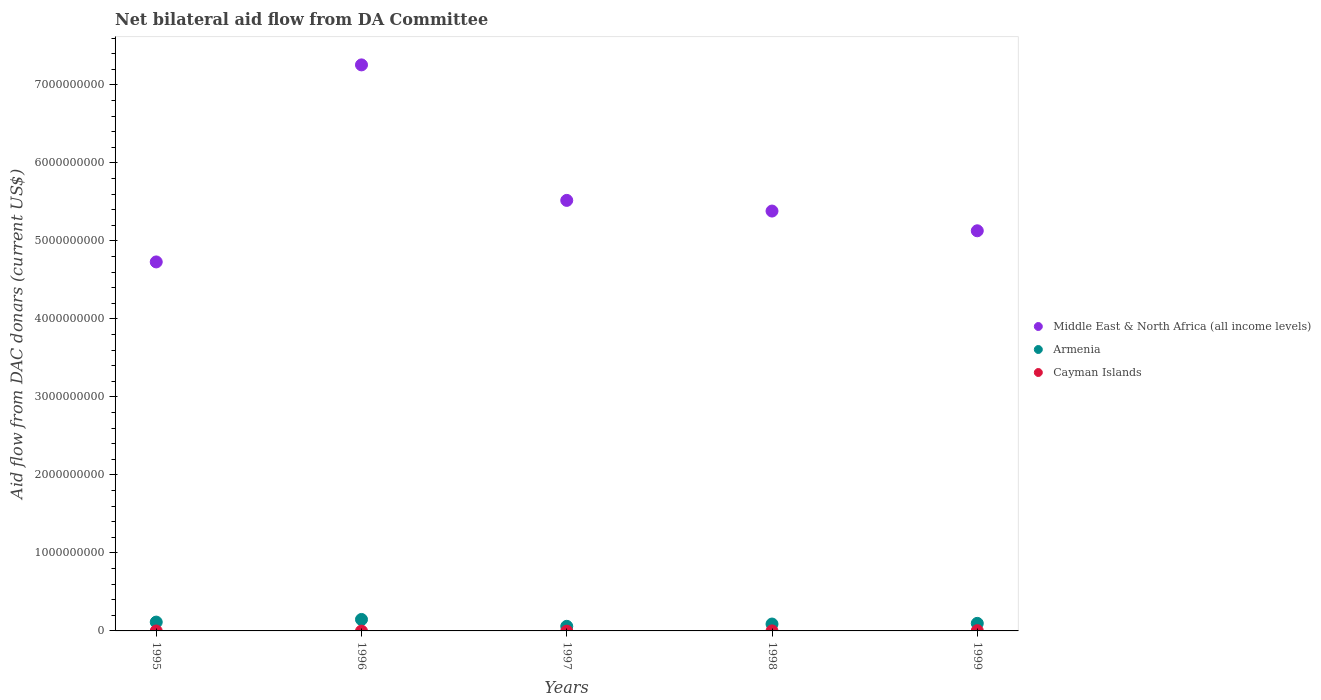How many different coloured dotlines are there?
Your answer should be very brief. 3. Is the number of dotlines equal to the number of legend labels?
Make the answer very short. No. What is the aid flow in in Middle East & North Africa (all income levels) in 1997?
Ensure brevity in your answer.  5.52e+09. Across all years, what is the maximum aid flow in in Cayman Islands?
Ensure brevity in your answer.  3.29e+06. Across all years, what is the minimum aid flow in in Armenia?
Provide a short and direct response. 5.89e+07. In which year was the aid flow in in Middle East & North Africa (all income levels) maximum?
Ensure brevity in your answer.  1996. What is the total aid flow in in Middle East & North Africa (all income levels) in the graph?
Your answer should be compact. 2.80e+1. What is the difference between the aid flow in in Armenia in 1998 and that in 1999?
Keep it short and to the point. -8.67e+06. What is the difference between the aid flow in in Armenia in 1999 and the aid flow in in Middle East & North Africa (all income levels) in 1996?
Ensure brevity in your answer.  -7.16e+09. What is the average aid flow in in Cayman Islands per year?
Provide a short and direct response. 7.04e+05. In the year 1998, what is the difference between the aid flow in in Armenia and aid flow in in Middle East & North Africa (all income levels)?
Provide a succinct answer. -5.29e+09. What is the ratio of the aid flow in in Middle East & North Africa (all income levels) in 1995 to that in 1999?
Provide a short and direct response. 0.92. Is the difference between the aid flow in in Armenia in 1997 and 1999 greater than the difference between the aid flow in in Middle East & North Africa (all income levels) in 1997 and 1999?
Give a very brief answer. No. What is the difference between the highest and the second highest aid flow in in Armenia?
Offer a very short reply. 3.38e+07. What is the difference between the highest and the lowest aid flow in in Cayman Islands?
Ensure brevity in your answer.  3.29e+06. In how many years, is the aid flow in in Middle East & North Africa (all income levels) greater than the average aid flow in in Middle East & North Africa (all income levels) taken over all years?
Offer a very short reply. 1. Is the sum of the aid flow in in Middle East & North Africa (all income levels) in 1997 and 1998 greater than the maximum aid flow in in Cayman Islands across all years?
Keep it short and to the point. Yes. Is it the case that in every year, the sum of the aid flow in in Armenia and aid flow in in Cayman Islands  is greater than the aid flow in in Middle East & North Africa (all income levels)?
Provide a short and direct response. No. How many years are there in the graph?
Offer a very short reply. 5. What is the difference between two consecutive major ticks on the Y-axis?
Provide a succinct answer. 1.00e+09. Where does the legend appear in the graph?
Ensure brevity in your answer.  Center right. How are the legend labels stacked?
Ensure brevity in your answer.  Vertical. What is the title of the graph?
Keep it short and to the point. Net bilateral aid flow from DA Committee. What is the label or title of the Y-axis?
Provide a short and direct response. Aid flow from DAC donars (current US$). What is the Aid flow from DAC donars (current US$) in Middle East & North Africa (all income levels) in 1995?
Make the answer very short. 4.73e+09. What is the Aid flow from DAC donars (current US$) in Armenia in 1995?
Give a very brief answer. 1.13e+08. What is the Aid flow from DAC donars (current US$) of Cayman Islands in 1995?
Your answer should be very brief. 0. What is the Aid flow from DAC donars (current US$) of Middle East & North Africa (all income levels) in 1996?
Provide a short and direct response. 7.26e+09. What is the Aid flow from DAC donars (current US$) of Armenia in 1996?
Provide a short and direct response. 1.47e+08. What is the Aid flow from DAC donars (current US$) in Cayman Islands in 1996?
Offer a terse response. 0. What is the Aid flow from DAC donars (current US$) of Middle East & North Africa (all income levels) in 1997?
Your response must be concise. 5.52e+09. What is the Aid flow from DAC donars (current US$) in Armenia in 1997?
Ensure brevity in your answer.  5.89e+07. What is the Aid flow from DAC donars (current US$) in Cayman Islands in 1997?
Ensure brevity in your answer.  0. What is the Aid flow from DAC donars (current US$) in Middle East & North Africa (all income levels) in 1998?
Your response must be concise. 5.38e+09. What is the Aid flow from DAC donars (current US$) of Armenia in 1998?
Your answer should be compact. 8.82e+07. What is the Aid flow from DAC donars (current US$) in Middle East & North Africa (all income levels) in 1999?
Your answer should be very brief. 5.13e+09. What is the Aid flow from DAC donars (current US$) of Armenia in 1999?
Offer a very short reply. 9.69e+07. What is the Aid flow from DAC donars (current US$) in Cayman Islands in 1999?
Ensure brevity in your answer.  3.29e+06. Across all years, what is the maximum Aid flow from DAC donars (current US$) in Middle East & North Africa (all income levels)?
Give a very brief answer. 7.26e+09. Across all years, what is the maximum Aid flow from DAC donars (current US$) in Armenia?
Your response must be concise. 1.47e+08. Across all years, what is the maximum Aid flow from DAC donars (current US$) in Cayman Islands?
Your answer should be very brief. 3.29e+06. Across all years, what is the minimum Aid flow from DAC donars (current US$) in Middle East & North Africa (all income levels)?
Provide a short and direct response. 4.73e+09. Across all years, what is the minimum Aid flow from DAC donars (current US$) in Armenia?
Provide a short and direct response. 5.89e+07. What is the total Aid flow from DAC donars (current US$) in Middle East & North Africa (all income levels) in the graph?
Your response must be concise. 2.80e+1. What is the total Aid flow from DAC donars (current US$) in Armenia in the graph?
Make the answer very short. 5.04e+08. What is the total Aid flow from DAC donars (current US$) in Cayman Islands in the graph?
Keep it short and to the point. 3.52e+06. What is the difference between the Aid flow from DAC donars (current US$) of Middle East & North Africa (all income levels) in 1995 and that in 1996?
Offer a terse response. -2.53e+09. What is the difference between the Aid flow from DAC donars (current US$) in Armenia in 1995 and that in 1996?
Make the answer very short. -3.38e+07. What is the difference between the Aid flow from DAC donars (current US$) in Middle East & North Africa (all income levels) in 1995 and that in 1997?
Offer a very short reply. -7.89e+08. What is the difference between the Aid flow from DAC donars (current US$) of Armenia in 1995 and that in 1997?
Provide a short and direct response. 5.43e+07. What is the difference between the Aid flow from DAC donars (current US$) in Middle East & North Africa (all income levels) in 1995 and that in 1998?
Ensure brevity in your answer.  -6.52e+08. What is the difference between the Aid flow from DAC donars (current US$) of Armenia in 1995 and that in 1998?
Ensure brevity in your answer.  2.50e+07. What is the difference between the Aid flow from DAC donars (current US$) of Middle East & North Africa (all income levels) in 1995 and that in 1999?
Offer a very short reply. -3.99e+08. What is the difference between the Aid flow from DAC donars (current US$) of Armenia in 1995 and that in 1999?
Keep it short and to the point. 1.63e+07. What is the difference between the Aid flow from DAC donars (current US$) of Middle East & North Africa (all income levels) in 1996 and that in 1997?
Offer a very short reply. 1.74e+09. What is the difference between the Aid flow from DAC donars (current US$) in Armenia in 1996 and that in 1997?
Keep it short and to the point. 8.81e+07. What is the difference between the Aid flow from DAC donars (current US$) in Middle East & North Africa (all income levels) in 1996 and that in 1998?
Your response must be concise. 1.87e+09. What is the difference between the Aid flow from DAC donars (current US$) in Armenia in 1996 and that in 1998?
Keep it short and to the point. 5.88e+07. What is the difference between the Aid flow from DAC donars (current US$) of Middle East & North Africa (all income levels) in 1996 and that in 1999?
Provide a short and direct response. 2.13e+09. What is the difference between the Aid flow from DAC donars (current US$) in Armenia in 1996 and that in 1999?
Offer a very short reply. 5.01e+07. What is the difference between the Aid flow from DAC donars (current US$) of Middle East & North Africa (all income levels) in 1997 and that in 1998?
Provide a succinct answer. 1.37e+08. What is the difference between the Aid flow from DAC donars (current US$) of Armenia in 1997 and that in 1998?
Your response must be concise. -2.93e+07. What is the difference between the Aid flow from DAC donars (current US$) of Middle East & North Africa (all income levels) in 1997 and that in 1999?
Offer a very short reply. 3.90e+08. What is the difference between the Aid flow from DAC donars (current US$) in Armenia in 1997 and that in 1999?
Your answer should be compact. -3.80e+07. What is the difference between the Aid flow from DAC donars (current US$) of Middle East & North Africa (all income levels) in 1998 and that in 1999?
Your answer should be very brief. 2.53e+08. What is the difference between the Aid flow from DAC donars (current US$) in Armenia in 1998 and that in 1999?
Offer a very short reply. -8.67e+06. What is the difference between the Aid flow from DAC donars (current US$) of Cayman Islands in 1998 and that in 1999?
Your answer should be very brief. -3.06e+06. What is the difference between the Aid flow from DAC donars (current US$) in Middle East & North Africa (all income levels) in 1995 and the Aid flow from DAC donars (current US$) in Armenia in 1996?
Your response must be concise. 4.58e+09. What is the difference between the Aid flow from DAC donars (current US$) in Middle East & North Africa (all income levels) in 1995 and the Aid flow from DAC donars (current US$) in Armenia in 1997?
Provide a short and direct response. 4.67e+09. What is the difference between the Aid flow from DAC donars (current US$) in Middle East & North Africa (all income levels) in 1995 and the Aid flow from DAC donars (current US$) in Armenia in 1998?
Make the answer very short. 4.64e+09. What is the difference between the Aid flow from DAC donars (current US$) in Middle East & North Africa (all income levels) in 1995 and the Aid flow from DAC donars (current US$) in Cayman Islands in 1998?
Offer a very short reply. 4.73e+09. What is the difference between the Aid flow from DAC donars (current US$) in Armenia in 1995 and the Aid flow from DAC donars (current US$) in Cayman Islands in 1998?
Provide a short and direct response. 1.13e+08. What is the difference between the Aid flow from DAC donars (current US$) in Middle East & North Africa (all income levels) in 1995 and the Aid flow from DAC donars (current US$) in Armenia in 1999?
Offer a terse response. 4.63e+09. What is the difference between the Aid flow from DAC donars (current US$) of Middle East & North Africa (all income levels) in 1995 and the Aid flow from DAC donars (current US$) of Cayman Islands in 1999?
Your response must be concise. 4.73e+09. What is the difference between the Aid flow from DAC donars (current US$) of Armenia in 1995 and the Aid flow from DAC donars (current US$) of Cayman Islands in 1999?
Ensure brevity in your answer.  1.10e+08. What is the difference between the Aid flow from DAC donars (current US$) in Middle East & North Africa (all income levels) in 1996 and the Aid flow from DAC donars (current US$) in Armenia in 1997?
Offer a very short reply. 7.20e+09. What is the difference between the Aid flow from DAC donars (current US$) in Middle East & North Africa (all income levels) in 1996 and the Aid flow from DAC donars (current US$) in Armenia in 1998?
Give a very brief answer. 7.17e+09. What is the difference between the Aid flow from DAC donars (current US$) in Middle East & North Africa (all income levels) in 1996 and the Aid flow from DAC donars (current US$) in Cayman Islands in 1998?
Provide a short and direct response. 7.26e+09. What is the difference between the Aid flow from DAC donars (current US$) of Armenia in 1996 and the Aid flow from DAC donars (current US$) of Cayman Islands in 1998?
Ensure brevity in your answer.  1.47e+08. What is the difference between the Aid flow from DAC donars (current US$) in Middle East & North Africa (all income levels) in 1996 and the Aid flow from DAC donars (current US$) in Armenia in 1999?
Make the answer very short. 7.16e+09. What is the difference between the Aid flow from DAC donars (current US$) in Middle East & North Africa (all income levels) in 1996 and the Aid flow from DAC donars (current US$) in Cayman Islands in 1999?
Make the answer very short. 7.25e+09. What is the difference between the Aid flow from DAC donars (current US$) in Armenia in 1996 and the Aid flow from DAC donars (current US$) in Cayman Islands in 1999?
Your answer should be compact. 1.44e+08. What is the difference between the Aid flow from DAC donars (current US$) in Middle East & North Africa (all income levels) in 1997 and the Aid flow from DAC donars (current US$) in Armenia in 1998?
Make the answer very short. 5.43e+09. What is the difference between the Aid flow from DAC donars (current US$) in Middle East & North Africa (all income levels) in 1997 and the Aid flow from DAC donars (current US$) in Cayman Islands in 1998?
Ensure brevity in your answer.  5.52e+09. What is the difference between the Aid flow from DAC donars (current US$) in Armenia in 1997 and the Aid flow from DAC donars (current US$) in Cayman Islands in 1998?
Your answer should be very brief. 5.87e+07. What is the difference between the Aid flow from DAC donars (current US$) in Middle East & North Africa (all income levels) in 1997 and the Aid flow from DAC donars (current US$) in Armenia in 1999?
Keep it short and to the point. 5.42e+09. What is the difference between the Aid flow from DAC donars (current US$) of Middle East & North Africa (all income levels) in 1997 and the Aid flow from DAC donars (current US$) of Cayman Islands in 1999?
Keep it short and to the point. 5.52e+09. What is the difference between the Aid flow from DAC donars (current US$) in Armenia in 1997 and the Aid flow from DAC donars (current US$) in Cayman Islands in 1999?
Give a very brief answer. 5.56e+07. What is the difference between the Aid flow from DAC donars (current US$) in Middle East & North Africa (all income levels) in 1998 and the Aid flow from DAC donars (current US$) in Armenia in 1999?
Ensure brevity in your answer.  5.29e+09. What is the difference between the Aid flow from DAC donars (current US$) of Middle East & North Africa (all income levels) in 1998 and the Aid flow from DAC donars (current US$) of Cayman Islands in 1999?
Ensure brevity in your answer.  5.38e+09. What is the difference between the Aid flow from DAC donars (current US$) in Armenia in 1998 and the Aid flow from DAC donars (current US$) in Cayman Islands in 1999?
Your answer should be compact. 8.49e+07. What is the average Aid flow from DAC donars (current US$) of Middle East & North Africa (all income levels) per year?
Give a very brief answer. 5.60e+09. What is the average Aid flow from DAC donars (current US$) of Armenia per year?
Give a very brief answer. 1.01e+08. What is the average Aid flow from DAC donars (current US$) of Cayman Islands per year?
Your answer should be compact. 7.04e+05. In the year 1995, what is the difference between the Aid flow from DAC donars (current US$) in Middle East & North Africa (all income levels) and Aid flow from DAC donars (current US$) in Armenia?
Offer a terse response. 4.62e+09. In the year 1996, what is the difference between the Aid flow from DAC donars (current US$) in Middle East & North Africa (all income levels) and Aid flow from DAC donars (current US$) in Armenia?
Provide a succinct answer. 7.11e+09. In the year 1997, what is the difference between the Aid flow from DAC donars (current US$) of Middle East & North Africa (all income levels) and Aid flow from DAC donars (current US$) of Armenia?
Keep it short and to the point. 5.46e+09. In the year 1998, what is the difference between the Aid flow from DAC donars (current US$) in Middle East & North Africa (all income levels) and Aid flow from DAC donars (current US$) in Armenia?
Your response must be concise. 5.29e+09. In the year 1998, what is the difference between the Aid flow from DAC donars (current US$) in Middle East & North Africa (all income levels) and Aid flow from DAC donars (current US$) in Cayman Islands?
Offer a very short reply. 5.38e+09. In the year 1998, what is the difference between the Aid flow from DAC donars (current US$) in Armenia and Aid flow from DAC donars (current US$) in Cayman Islands?
Your response must be concise. 8.80e+07. In the year 1999, what is the difference between the Aid flow from DAC donars (current US$) of Middle East & North Africa (all income levels) and Aid flow from DAC donars (current US$) of Armenia?
Ensure brevity in your answer.  5.03e+09. In the year 1999, what is the difference between the Aid flow from DAC donars (current US$) of Middle East & North Africa (all income levels) and Aid flow from DAC donars (current US$) of Cayman Islands?
Your answer should be very brief. 5.13e+09. In the year 1999, what is the difference between the Aid flow from DAC donars (current US$) of Armenia and Aid flow from DAC donars (current US$) of Cayman Islands?
Offer a terse response. 9.36e+07. What is the ratio of the Aid flow from DAC donars (current US$) of Middle East & North Africa (all income levels) in 1995 to that in 1996?
Give a very brief answer. 0.65. What is the ratio of the Aid flow from DAC donars (current US$) of Armenia in 1995 to that in 1996?
Keep it short and to the point. 0.77. What is the ratio of the Aid flow from DAC donars (current US$) of Armenia in 1995 to that in 1997?
Your answer should be very brief. 1.92. What is the ratio of the Aid flow from DAC donars (current US$) in Middle East & North Africa (all income levels) in 1995 to that in 1998?
Offer a very short reply. 0.88. What is the ratio of the Aid flow from DAC donars (current US$) of Armenia in 1995 to that in 1998?
Provide a short and direct response. 1.28. What is the ratio of the Aid flow from DAC donars (current US$) of Middle East & North Africa (all income levels) in 1995 to that in 1999?
Make the answer very short. 0.92. What is the ratio of the Aid flow from DAC donars (current US$) of Armenia in 1995 to that in 1999?
Ensure brevity in your answer.  1.17. What is the ratio of the Aid flow from DAC donars (current US$) in Middle East & North Africa (all income levels) in 1996 to that in 1997?
Your answer should be compact. 1.31. What is the ratio of the Aid flow from DAC donars (current US$) in Armenia in 1996 to that in 1997?
Provide a succinct answer. 2.49. What is the ratio of the Aid flow from DAC donars (current US$) in Middle East & North Africa (all income levels) in 1996 to that in 1998?
Offer a terse response. 1.35. What is the ratio of the Aid flow from DAC donars (current US$) in Armenia in 1996 to that in 1998?
Provide a short and direct response. 1.67. What is the ratio of the Aid flow from DAC donars (current US$) of Middle East & North Africa (all income levels) in 1996 to that in 1999?
Provide a short and direct response. 1.41. What is the ratio of the Aid flow from DAC donars (current US$) of Armenia in 1996 to that in 1999?
Keep it short and to the point. 1.52. What is the ratio of the Aid flow from DAC donars (current US$) of Middle East & North Africa (all income levels) in 1997 to that in 1998?
Offer a terse response. 1.03. What is the ratio of the Aid flow from DAC donars (current US$) in Armenia in 1997 to that in 1998?
Offer a terse response. 0.67. What is the ratio of the Aid flow from DAC donars (current US$) of Middle East & North Africa (all income levels) in 1997 to that in 1999?
Make the answer very short. 1.08. What is the ratio of the Aid flow from DAC donars (current US$) of Armenia in 1997 to that in 1999?
Keep it short and to the point. 0.61. What is the ratio of the Aid flow from DAC donars (current US$) of Middle East & North Africa (all income levels) in 1998 to that in 1999?
Provide a short and direct response. 1.05. What is the ratio of the Aid flow from DAC donars (current US$) in Armenia in 1998 to that in 1999?
Your response must be concise. 0.91. What is the ratio of the Aid flow from DAC donars (current US$) of Cayman Islands in 1998 to that in 1999?
Offer a terse response. 0.07. What is the difference between the highest and the second highest Aid flow from DAC donars (current US$) of Middle East & North Africa (all income levels)?
Make the answer very short. 1.74e+09. What is the difference between the highest and the second highest Aid flow from DAC donars (current US$) of Armenia?
Offer a terse response. 3.38e+07. What is the difference between the highest and the lowest Aid flow from DAC donars (current US$) in Middle East & North Africa (all income levels)?
Your response must be concise. 2.53e+09. What is the difference between the highest and the lowest Aid flow from DAC donars (current US$) in Armenia?
Ensure brevity in your answer.  8.81e+07. What is the difference between the highest and the lowest Aid flow from DAC donars (current US$) of Cayman Islands?
Provide a short and direct response. 3.29e+06. 